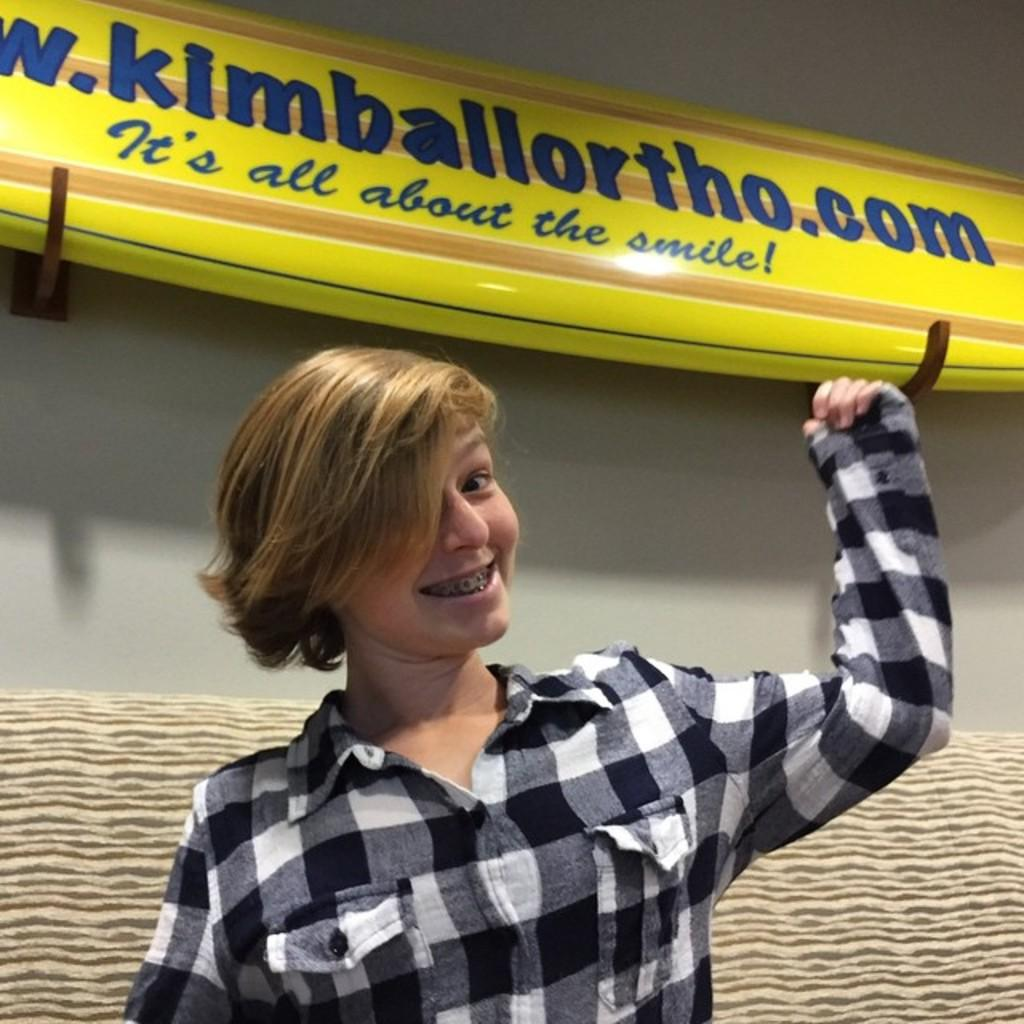What is the main subject of the image? The main subject of the image is a lady. What is the lady doing in the image? The lady is smiling in the image. What can be seen in the background of the image? There is a wall and a board in the background of the image. What type of salt is being used to draw on the board in the image? There is no salt or drawing on the board in the image. What time of day is it in the image? The time of day cannot be determined from the image, as there is no specific indication of the time. 